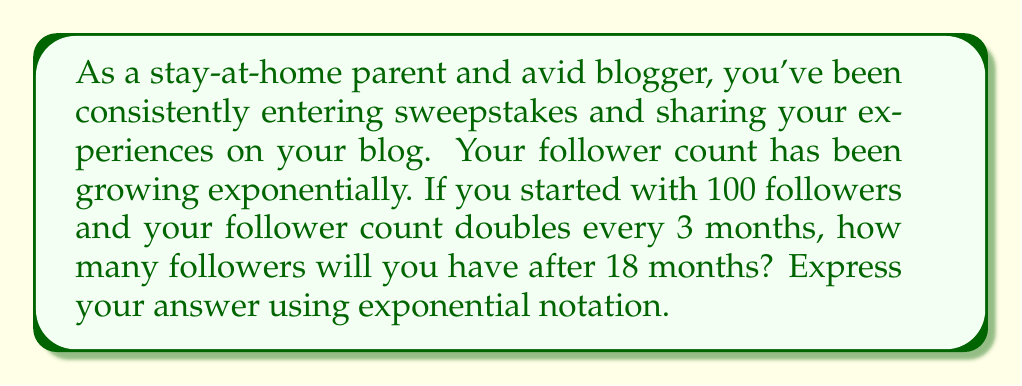Help me with this question. Let's approach this step-by-step:

1) We start with the basic exponential growth formula:

   $$ A = A_0 \cdot b^t $$

   Where:
   $A$ is the final amount
   $A_0$ is the initial amount
   $b$ is the growth factor
   $t$ is the number of time periods

2) We know:
   $A_0 = 100$ (initial followers)
   $b = 2$ (doubles every period)
   
3) We need to determine $t$:
   - The growth occurs every 3 months
   - We're looking at a span of 18 months
   - So, $t = 18 \div 3 = 6$ periods

4) Now we can plug these values into our formula:

   $$ A = 100 \cdot 2^6 $$

5) To calculate $2^6$:
   $$ 2^6 = 2 \cdot 2 \cdot 2 \cdot 2 \cdot 2 \cdot 2 = 64 $$

6) Therefore:
   $$ A = 100 \cdot 64 = 6400 $$

So, after 18 months, you will have 6400 followers.
Answer: $6400$ or $6.4 \times 10^3$ followers 